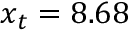Convert formula to latex. <formula><loc_0><loc_0><loc_500><loc_500>x _ { t } = 8 . 6 8</formula> 